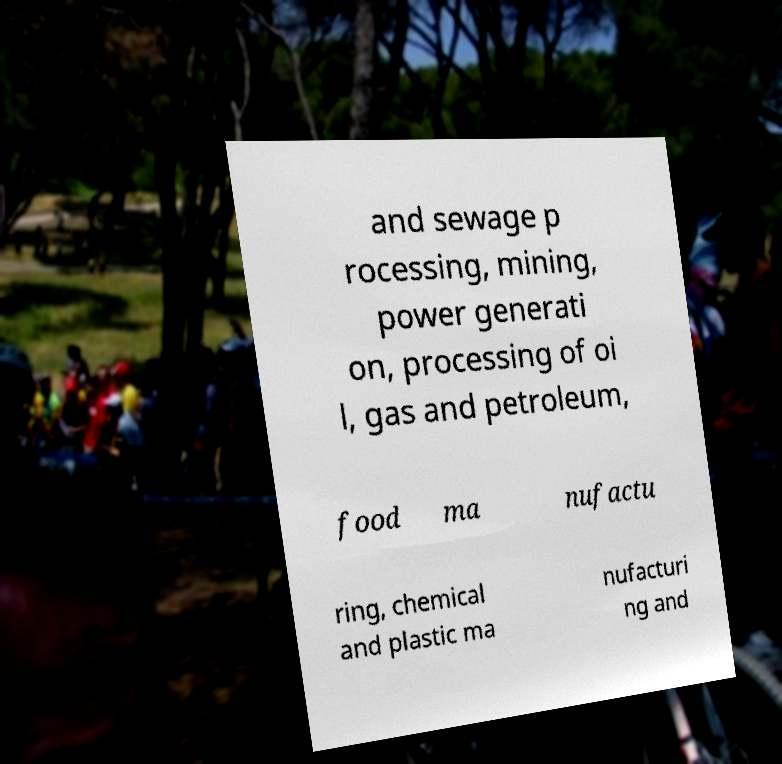There's text embedded in this image that I need extracted. Can you transcribe it verbatim? and sewage p rocessing, mining, power generati on, processing of oi l, gas and petroleum, food ma nufactu ring, chemical and plastic ma nufacturi ng and 